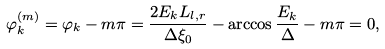<formula> <loc_0><loc_0><loc_500><loc_500>\varphi ^ { ( m ) } _ { k } = \varphi _ { k } - m \pi = \frac { 2 E _ { k } L _ { l , r } } { \Delta \xi _ { 0 } } - \arccos { \frac { E _ { k } } { \Delta } } - m \pi = 0 ,</formula> 